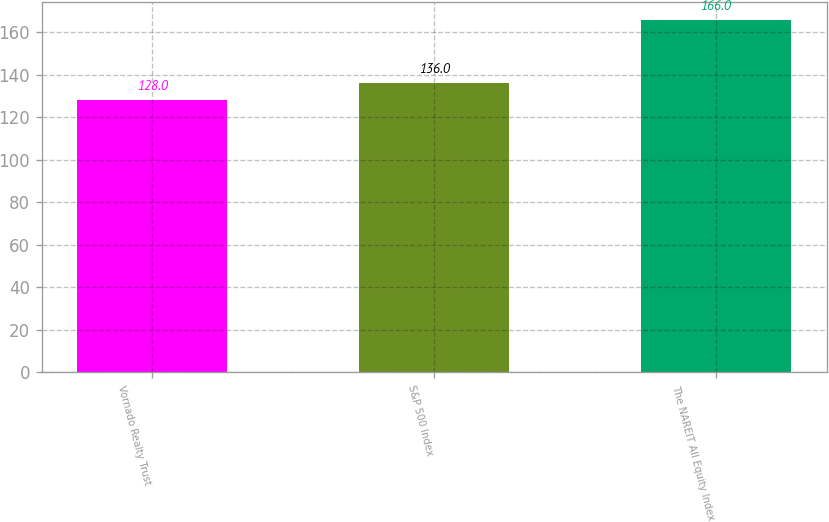<chart> <loc_0><loc_0><loc_500><loc_500><bar_chart><fcel>Vornado Realty Trust<fcel>S&P 500 Index<fcel>The NAREIT All Equity Index<nl><fcel>128<fcel>136<fcel>166<nl></chart> 